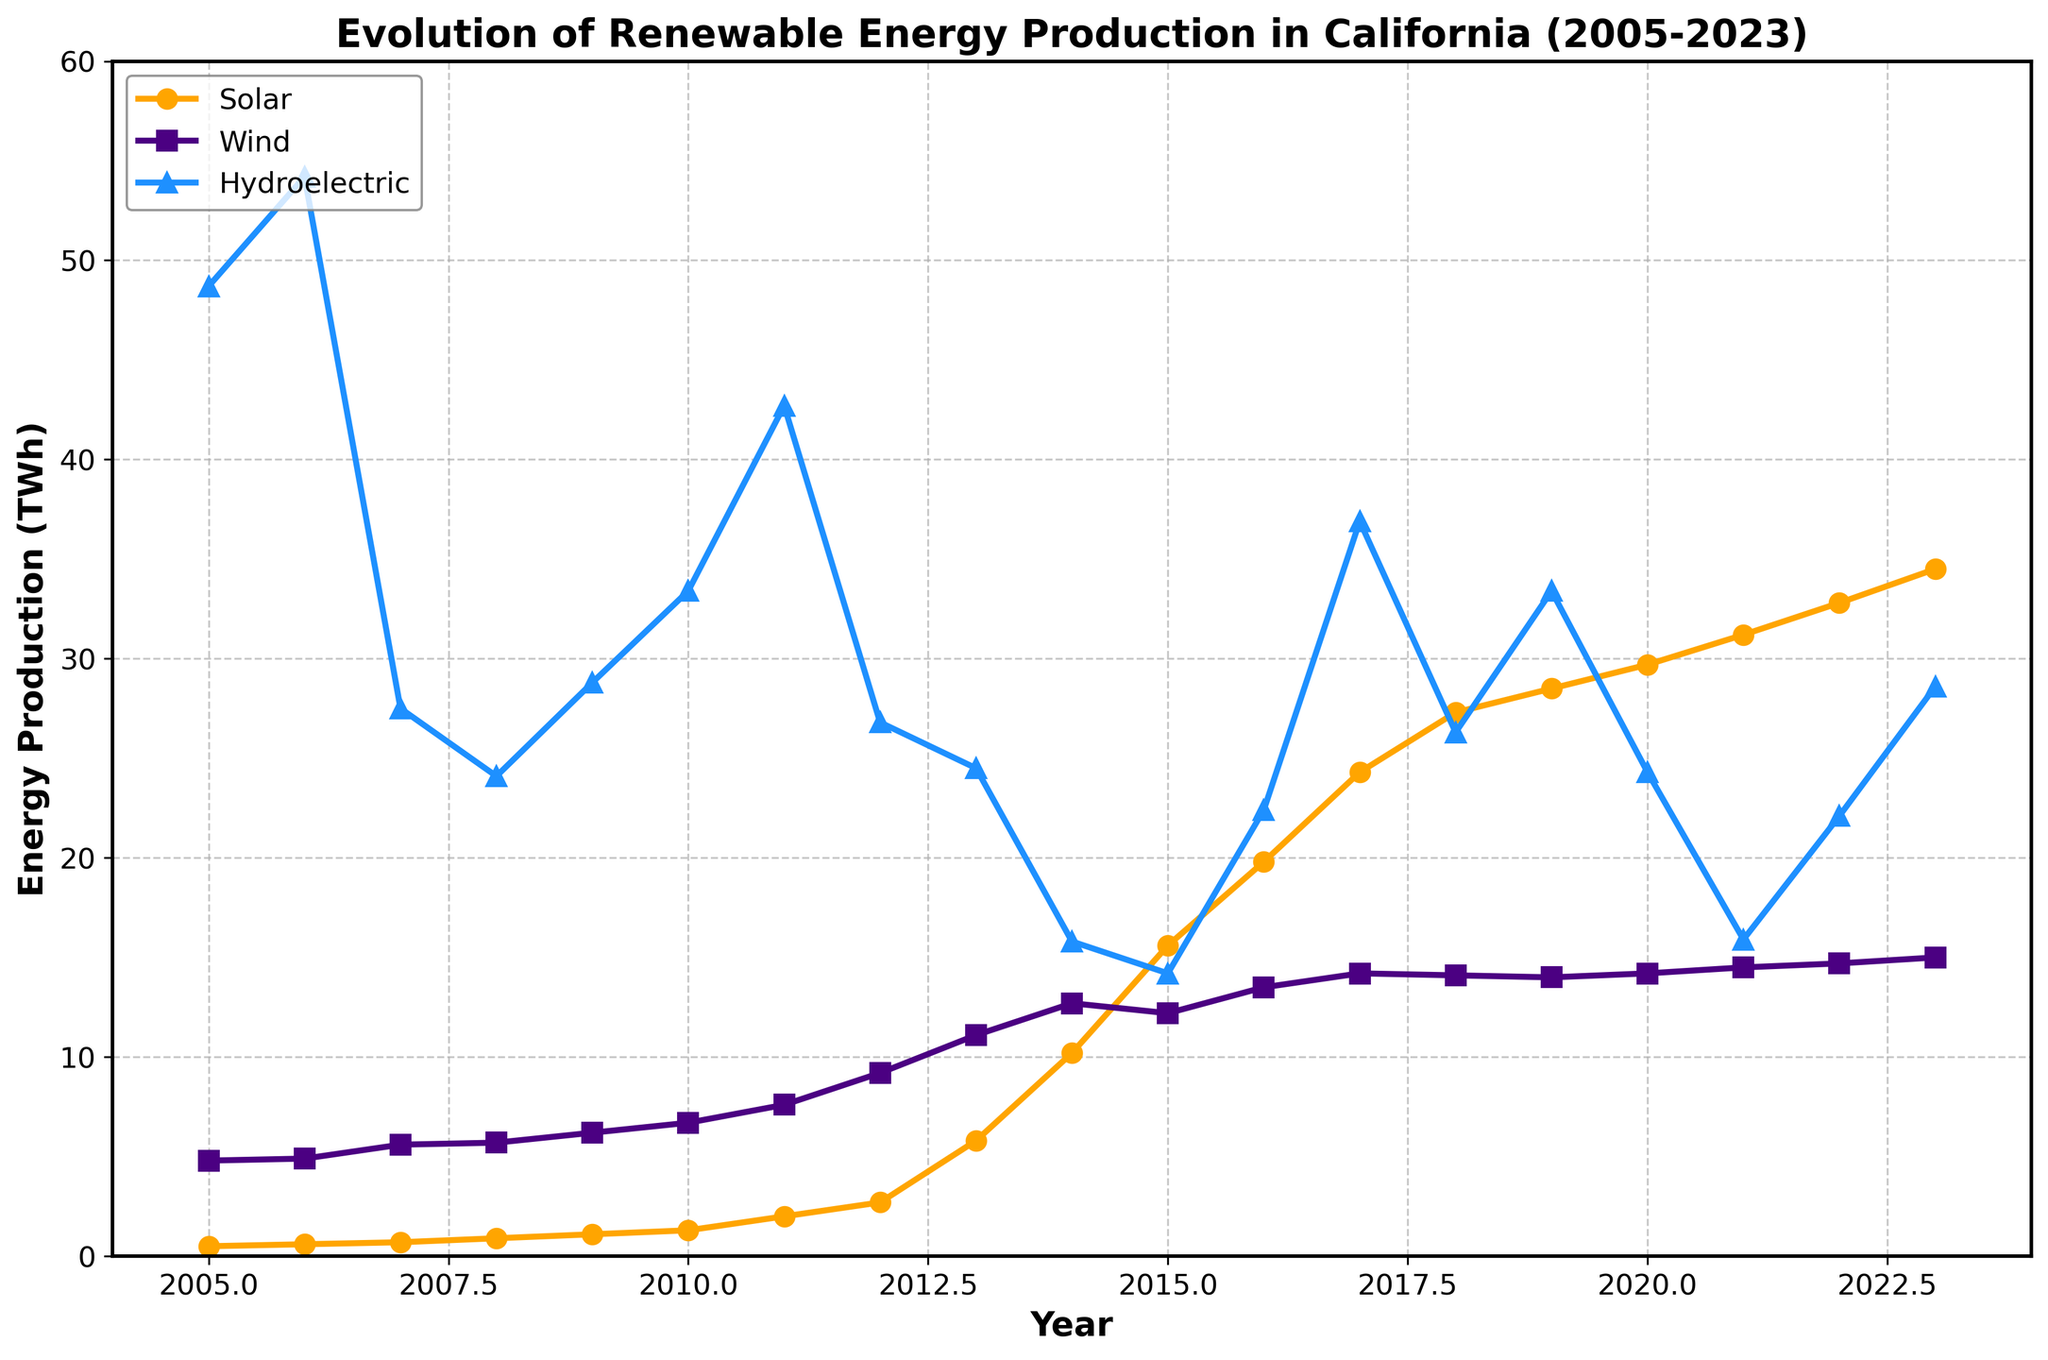What is the trend in solar energy production from 2005 to 2023? To determine the trend, observe the plot line for solar energy which starts at 0.5 TWh in 2005 and steadily increases to 34.5 TWh in 2023. This shows a continuous upward trend.
Answer: Continuous upward trend Which year saw the highest production of hydroelectric energy? Look for the peak point on the hydroelectric line plot. The highest point occurs in 2006 where it reaches 54.2 TWh.
Answer: 2006 How did wind energy production change between 2010 and 2015? Examine the wind energy line between the years 2010 to 2015. It increased from 6.7 TWh in 2010 to 12.2 TWh in 2015.
Answer: Increased What is the combined renewable energy production from solar and wind in 2023? Add the solar and wind values for the year 2023 on the plot; Solar: 34.5 TWh, Wind: 15 TWh. So, the sum is 34.5 + 15 = 49.5 TWh.
Answer: 49.5 TWh During which period did hydroelectric energy production experience the steepest decline? Identify the sharpest drop by observing the slope of the hydroelectric line. The steepest decline occurs between 2013 (24.5 TWh) and 2014 (15.8 TWh), a drop of 8.7 TWh.
Answer: 2013-2014 Compare the production of solar energy in 2010 and 2020. Which year had higher production and by how much? Evaluate the solar energy values for 2010 (1.3 TWh) and 2020 (29.7 TWh). Subtract to find the difference: 29.7 - 1.3 = 28.4 TWh. 2020 had higher production by 28.4 TWh.
Answer: 2020 by 28.4 TWh What visual indicator shows which energy sources increased over the given period? The upward slope of the lines for solar (orange) and wind (purple) indicate an increase, while hydroelectric (blue) shows fluctuations with no clear continuous upward trend.
Answer: Upward slope of solar (orange) and wind (purple) What is the average annual increase in solar energy production from 2005 to 2023? Subtract the starting value (2005: 0.5 TWh) from the ending value (2023: 34.5 TWh), then divide by the number of years (2023-2005 = 18 years): (34.5 - 0.5) / 18 = 1.89 TWh/year.
Answer: 1.89 TWh/year What was the difference in wind energy production between the highest and lowest years? Identify the highest wind production (2018: 14.1 TWh) and the lowest (2005: 4.8 TWh), then subtract: 14.1 - 4.8 = 9.3 TWh.
Answer: 9.3 TWh 